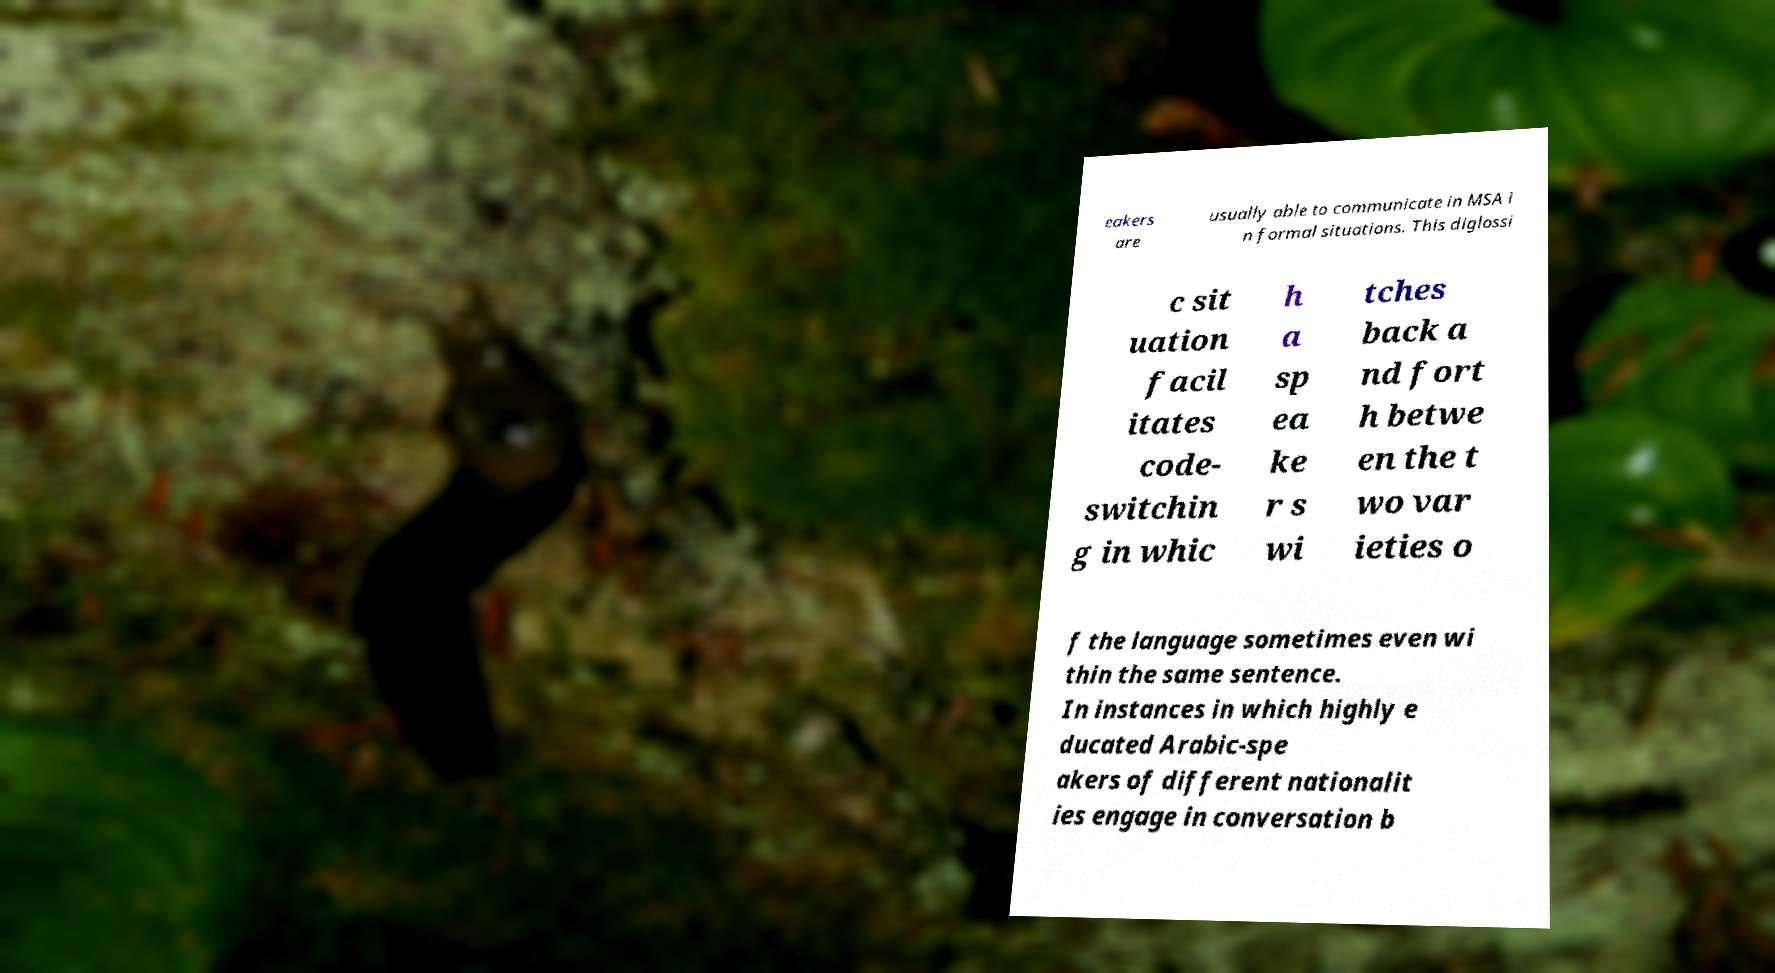I need the written content from this picture converted into text. Can you do that? eakers are usually able to communicate in MSA i n formal situations. This diglossi c sit uation facil itates code- switchin g in whic h a sp ea ke r s wi tches back a nd fort h betwe en the t wo var ieties o f the language sometimes even wi thin the same sentence. In instances in which highly e ducated Arabic-spe akers of different nationalit ies engage in conversation b 